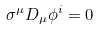<formula> <loc_0><loc_0><loc_500><loc_500>\sigma ^ { \mu } D _ { \mu } \phi ^ { i } = 0</formula> 